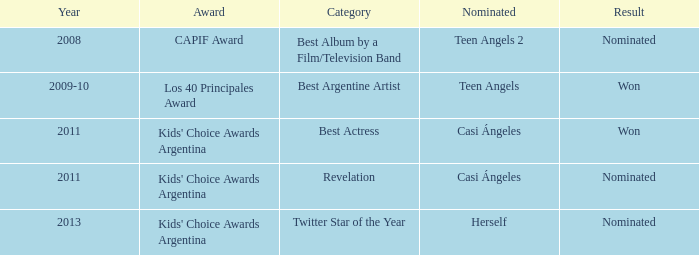What year was there a nomination for Best Actress at the Kids' Choice Awards Argentina? 2011.0. 